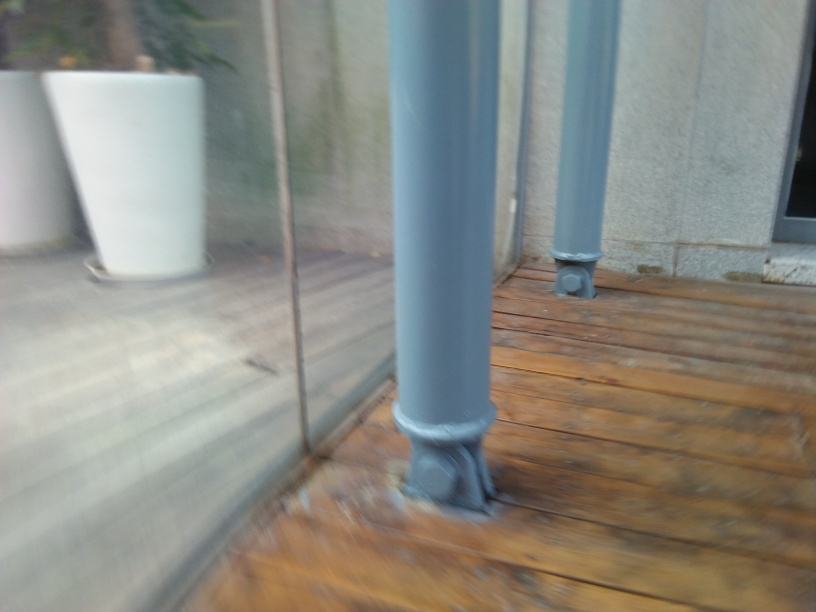Can you describe the colors that are predominant in this image? The image showcases muted tones, with grays visible on the pillars and a range of browns on the wooden planks on the ground. The plant container in the background adds a touch of white to the overall earthy color palette. 